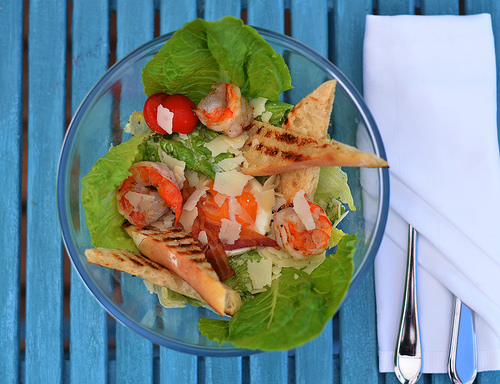<image>
Is the cheese on the lettuce? No. The cheese is not positioned on the lettuce. They may be near each other, but the cheese is not supported by or resting on top of the lettuce. Where is the fork in relation to the napkin? Is it under the napkin? Yes. The fork is positioned underneath the napkin, with the napkin above it in the vertical space. Where is the fork in relation to the napkin? Is it in front of the napkin? No. The fork is not in front of the napkin. The spatial positioning shows a different relationship between these objects. 